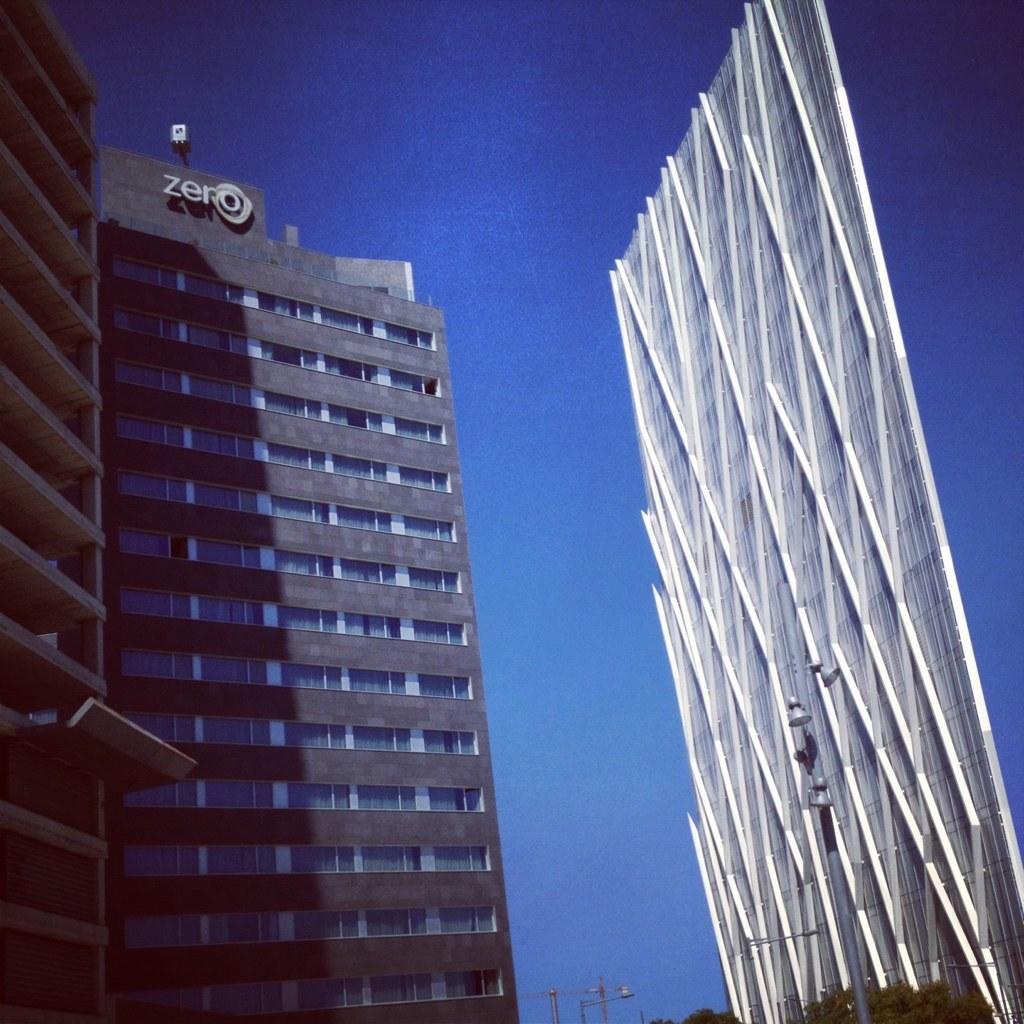Please provide a concise description of this image. In this image there is a building at left side of this image and there is some wall at right side of this image and there is a sky at top of this image, and there are some poles at bottom of this image. 